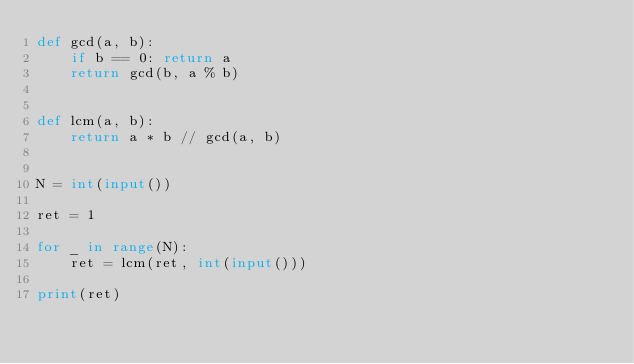Convert code to text. <code><loc_0><loc_0><loc_500><loc_500><_Python_>def gcd(a, b):
    if b == 0: return a
    return gcd(b, a % b)


def lcm(a, b):
    return a * b // gcd(a, b)


N = int(input())

ret = 1

for _ in range(N):
    ret = lcm(ret, int(input()))

print(ret)
</code> 